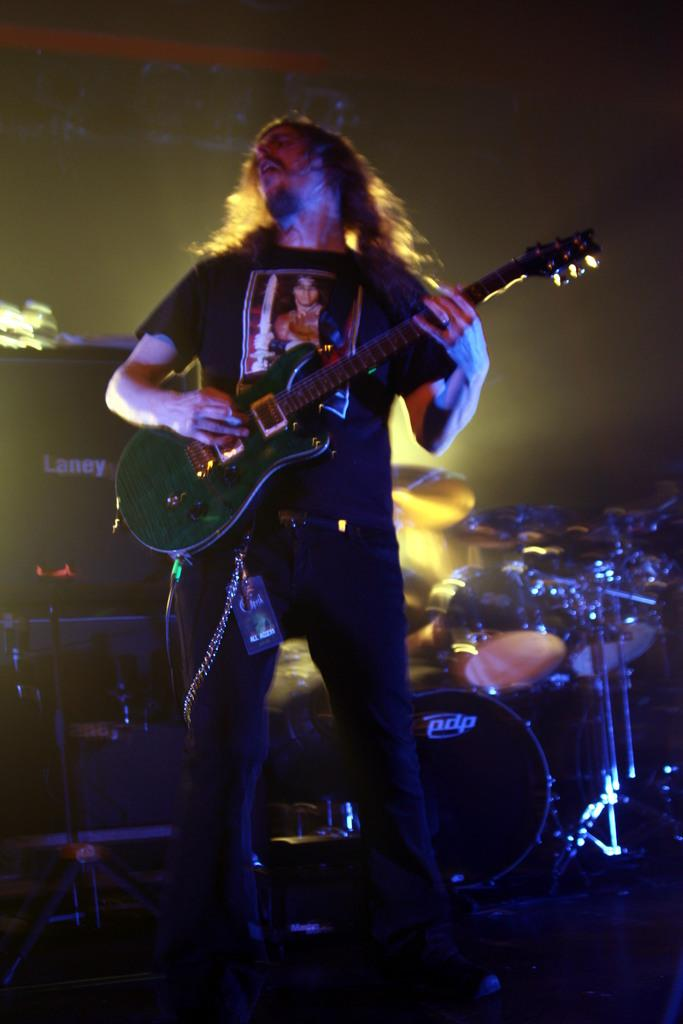What is the person in the image doing? The person is playing a guitar in the image. What musical instrument is visible behind the person? There are drums behind the person. What type of objects can be seen in the image besides musical instruments? There are electronic objects in the image. How would you describe the lighting in the image? The background of the image is dark. What type of popcorn is being served in the image? There is no popcorn present in the image. Can you see a needle being used by the person playing the guitar? There is no needle visible in the image; the person is playing a guitar. 